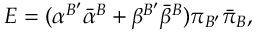Convert formula to latex. <formula><loc_0><loc_0><loc_500><loc_500>E = ( { \alpha } ^ { B ^ { \prime } } { \bar { \alpha } } ^ { B } + { \beta } ^ { B ^ { \prime } } { \bar { \beta } } ^ { B } ) { \pi } _ { B ^ { \prime } } { \bar { \pi } } _ { B } ,</formula> 